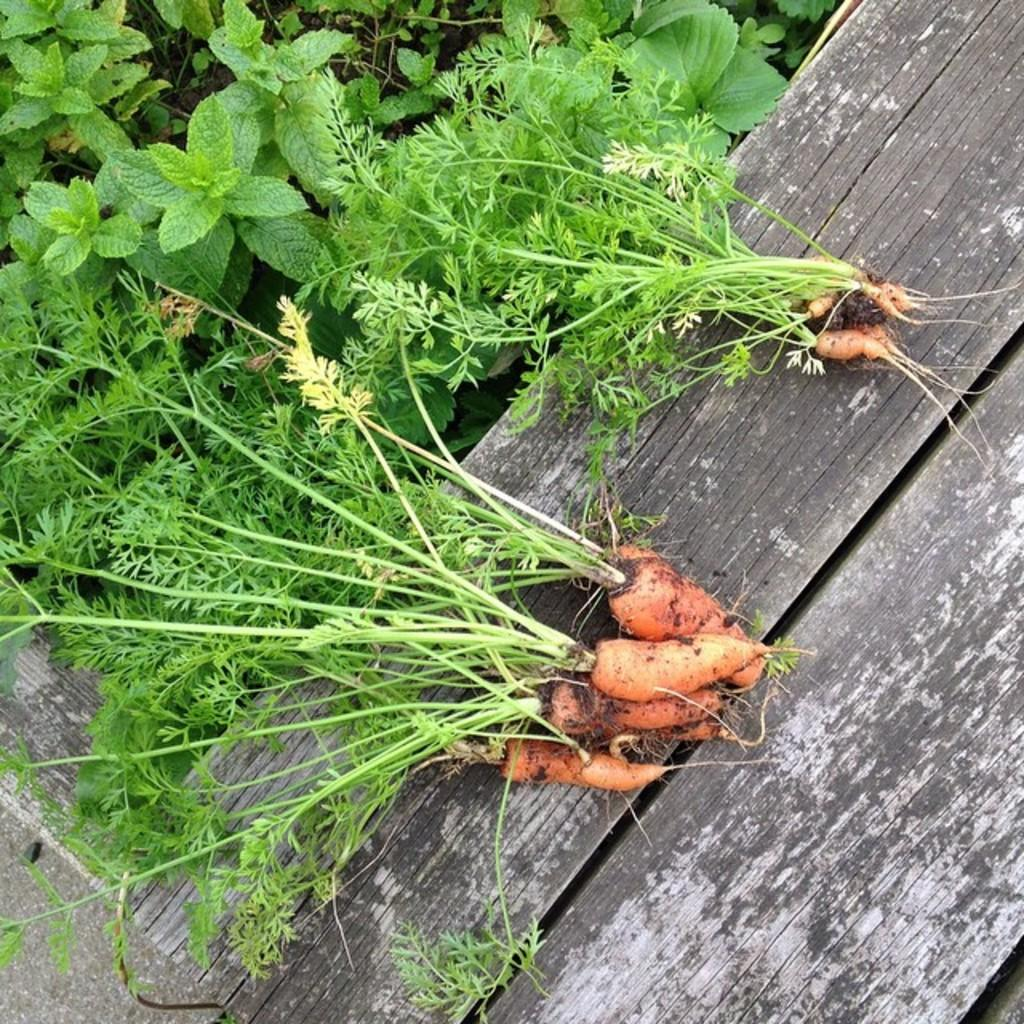What is placed on the bench in the image? There are carrots on the bench. What else can be seen in the image besides the carrots? There are plants in the image. What type of fang can be seen in the image? There is no fang present in the image. Can you tell me how many airports are visible in the image? There are no airports present in the image. 